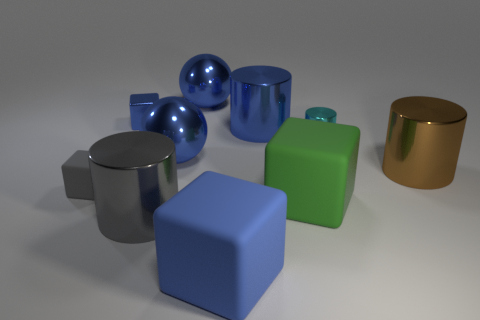Do the tiny object that is in front of the brown cylinder and the tiny metallic thing behind the small cyan object have the same shape?
Your answer should be compact. Yes. Do the big object on the right side of the big green rubber block and the blue block in front of the tiny cylinder have the same material?
Provide a short and direct response. No. Are the big blue cube and the brown thing made of the same material?
Keep it short and to the point. No. What number of objects are green matte spheres or shiny cylinders?
Give a very brief answer. 4. What number of blue shiny spheres have the same size as the green rubber block?
Offer a terse response. 2. The blue shiny thing that is to the right of the thing behind the blue metallic block is what shape?
Ensure brevity in your answer.  Cylinder. Are there fewer cyan cylinders than large rubber objects?
Your answer should be compact. Yes. There is a tiny rubber thing left of the big gray cylinder; what is its color?
Give a very brief answer. Gray. The cylinder that is both to the left of the brown metallic cylinder and on the right side of the large green rubber thing is made of what material?
Offer a very short reply. Metal. What is the shape of the tiny blue object that is made of the same material as the large brown cylinder?
Keep it short and to the point. Cube. 